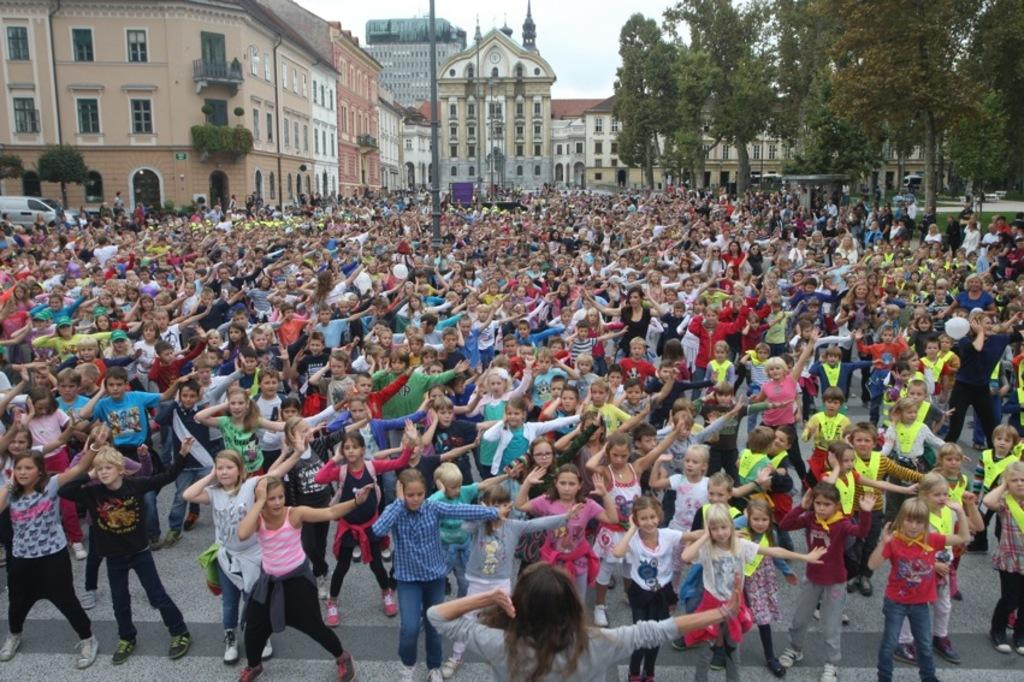How many people are in the image? There is a group of persons standing in the image. What can be seen in the background of the image? There are buildings, trees, and poles in the background of the image. What is the ground made of in the image? There is grass on the ground in the image. What is the condition of the sky in the image? The sky is cloudy in the image. Is there any transportation visible in the image? Yes, there is a car in the image. Can you see any monkeys climbing the trees in the image? There are no monkeys present in the image; it features a group of persons, buildings, trees, poles, grass, a car, and a cloudy sky. Is there a cobweb visible on any of the poles in the image? There is no mention of a cobweb in the image; it only features a group of persons, buildings, trees, poles, grass, a car, and a cloudy sky. 